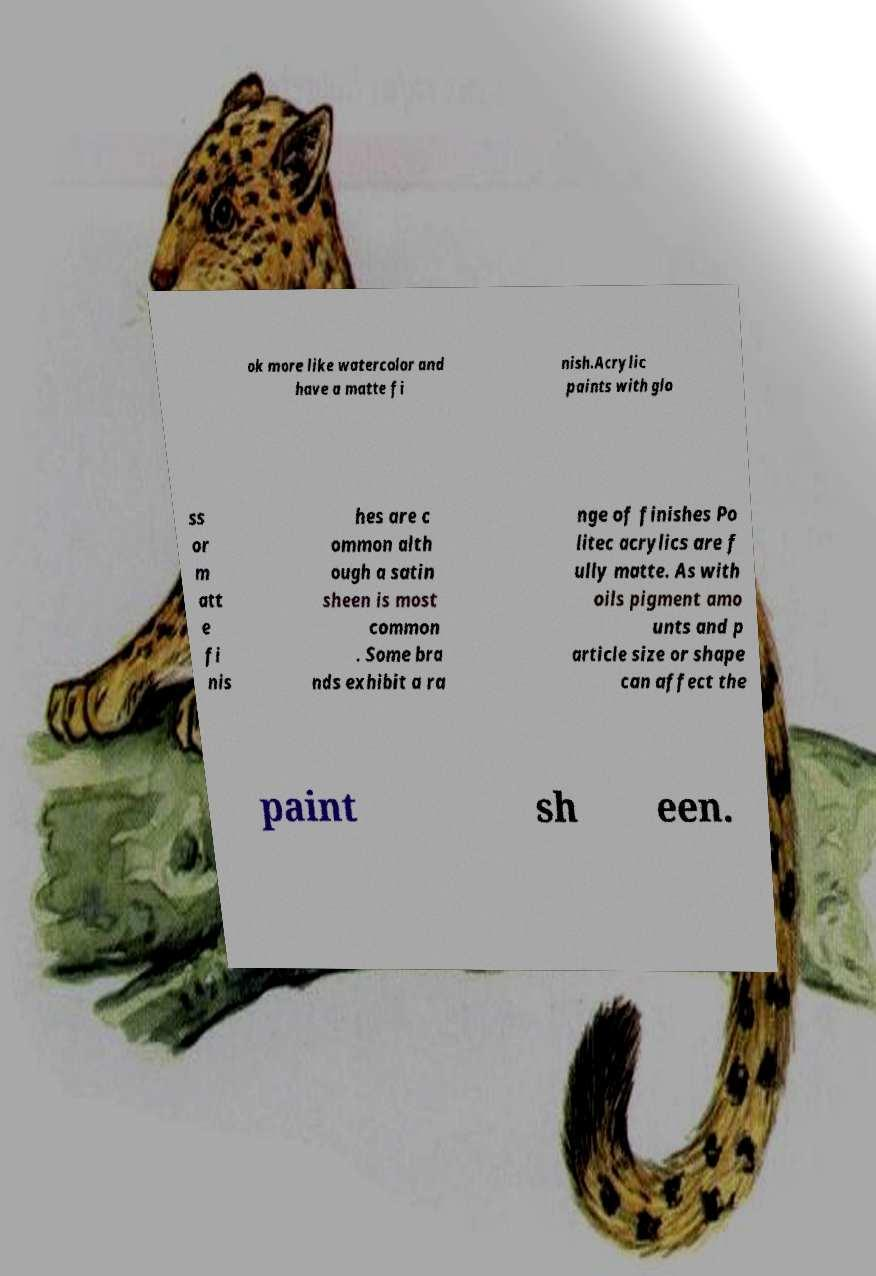Please identify and transcribe the text found in this image. ok more like watercolor and have a matte fi nish.Acrylic paints with glo ss or m att e fi nis hes are c ommon alth ough a satin sheen is most common . Some bra nds exhibit a ra nge of finishes Po litec acrylics are f ully matte. As with oils pigment amo unts and p article size or shape can affect the paint sh een. 